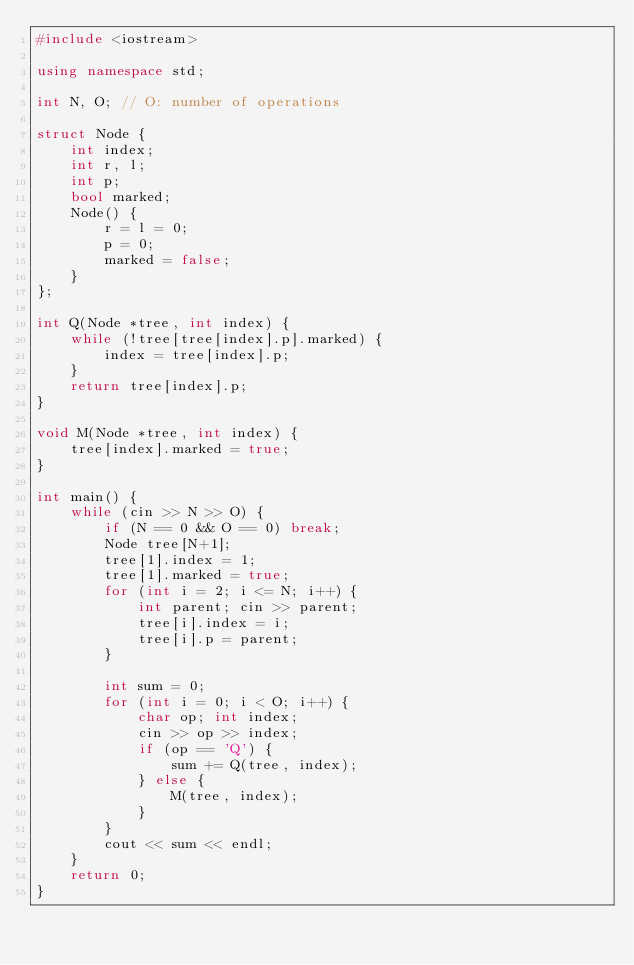Convert code to text. <code><loc_0><loc_0><loc_500><loc_500><_C++_>#include <iostream>

using namespace std;

int N, O; // O: number of operations

struct Node {
	int index;
	int r, l;
	int p;
	bool marked;
	Node() {
		r = l = 0;
		p = 0;
		marked = false;
	}
};

int Q(Node *tree, int index) {
	while (!tree[tree[index].p].marked) {
		index = tree[index].p;
	}
	return tree[index].p;
}

void M(Node *tree, int index) {
	tree[index].marked = true;
}

int main() {
	while (cin >> N >> O) {
		if (N == 0 && O == 0) break;
		Node tree[N+1];
		tree[1].index = 1;
		tree[1].marked = true;
		for (int i = 2; i <= N; i++) {
			int parent; cin >> parent;
			tree[i].index = i;
			tree[i].p = parent;
		}

		int sum = 0;
		for (int i = 0; i < O; i++) {
			char op; int index;
			cin >> op >> index;
			if (op == 'Q') {
				sum += Q(tree, index);
			} else {
				M(tree, index);
			}
		}
		cout << sum << endl;
	}
	return 0;
}</code> 